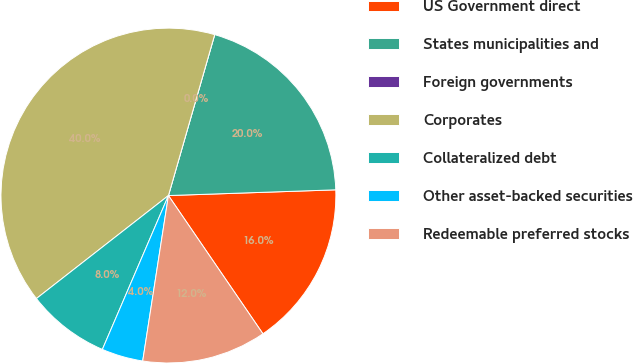Convert chart. <chart><loc_0><loc_0><loc_500><loc_500><pie_chart><fcel>US Government direct<fcel>States municipalities and<fcel>Foreign governments<fcel>Corporates<fcel>Collateralized debt<fcel>Other asset-backed securities<fcel>Redeemable preferred stocks<nl><fcel>16.0%<fcel>20.0%<fcel>0.0%<fcel>40.0%<fcel>8.0%<fcel>4.0%<fcel>12.0%<nl></chart> 